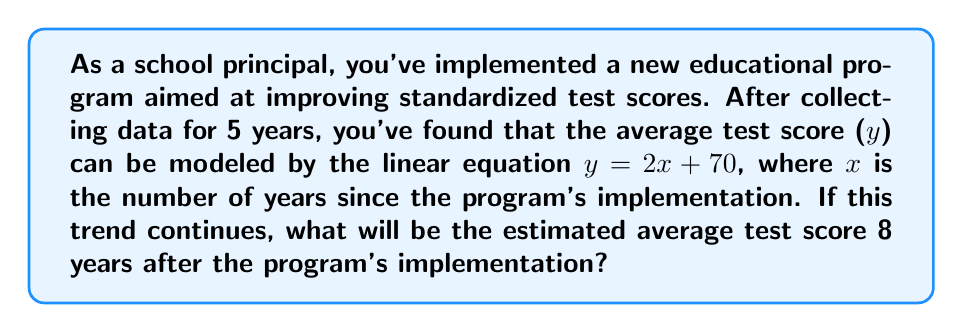Could you help me with this problem? Let's approach this step-by-step:

1) We are given the linear equation: $y = 2x + 70$
   Where:
   $y$ = average test score
   $x$ = number of years since program implementation
   
2) We need to find $y$ when $x = 8$ (8 years after implementation)

3) To solve, we simply substitute $x = 8$ into the equation:

   $y = 2(8) + 70$

4) Let's calculate:
   $y = 16 + 70$
   $y = 86$

5) Therefore, 8 years after the program's implementation, the estimated average test score will be 86.

This linear model suggests that the educational program is having a positive impact, with test scores increasing by 2 points each year on average.
Answer: 86 